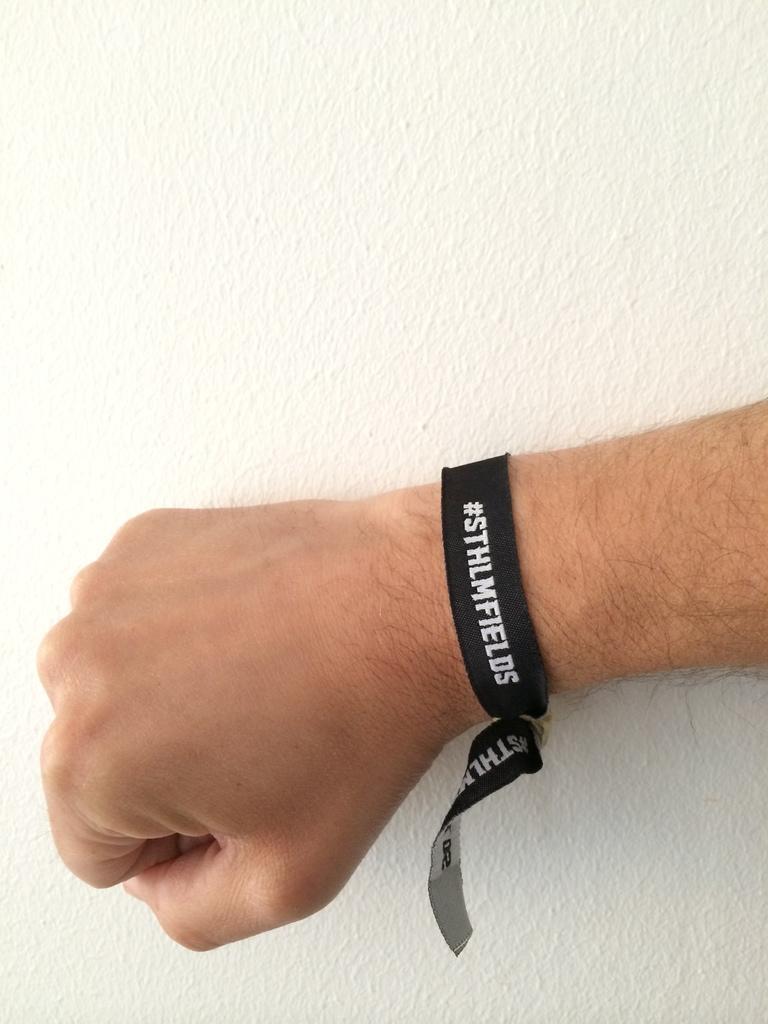How would you summarize this image in a sentence or two? In the image we can see there is a hand of a person on which there is a black band tied to the hand at the background there is a white wall. 